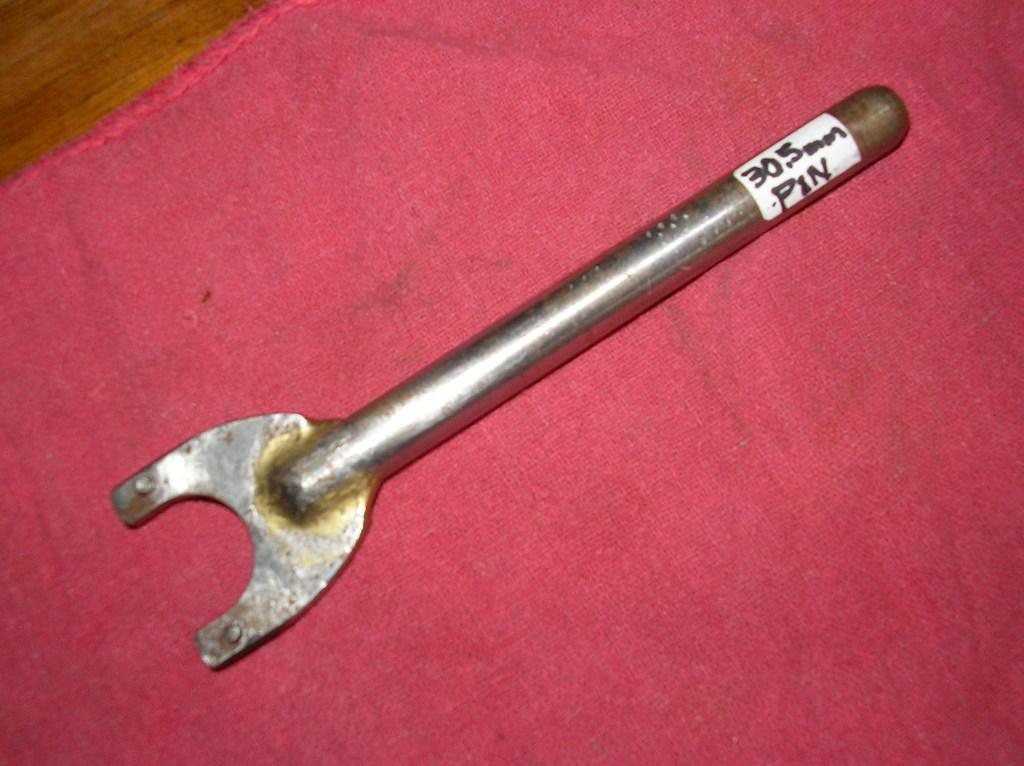Please provide a concise description of this image. In this image we can see a metal tool on a cloth on a platform. 